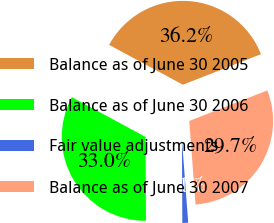Convert chart. <chart><loc_0><loc_0><loc_500><loc_500><pie_chart><fcel>Balance as of June 30 2005<fcel>Balance as of June 30 2006<fcel>Fair value adjustments<fcel>Balance as of June 30 2007<nl><fcel>36.18%<fcel>32.96%<fcel>1.12%<fcel>29.74%<nl></chart> 